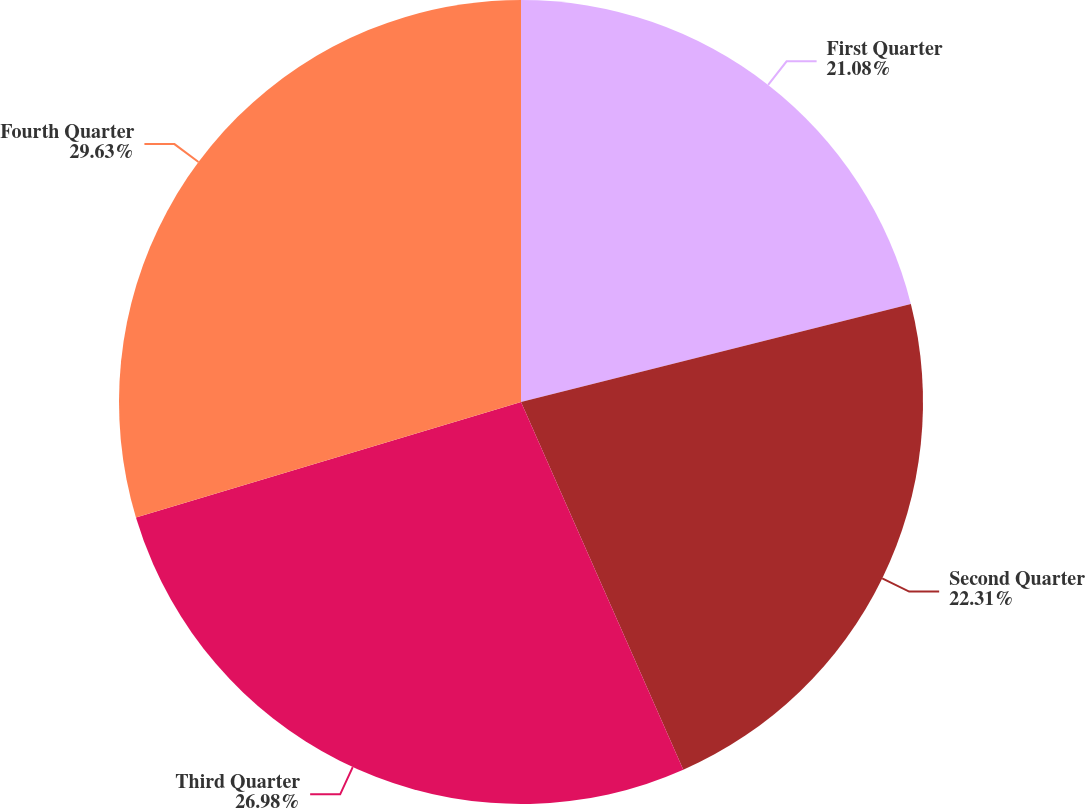<chart> <loc_0><loc_0><loc_500><loc_500><pie_chart><fcel>First Quarter<fcel>Second Quarter<fcel>Third Quarter<fcel>Fourth Quarter<nl><fcel>21.08%<fcel>22.31%<fcel>26.98%<fcel>29.64%<nl></chart> 